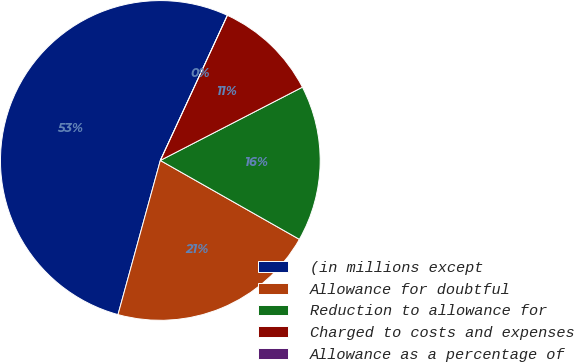Convert chart. <chart><loc_0><loc_0><loc_500><loc_500><pie_chart><fcel>(in millions except<fcel>Allowance for doubtful<fcel>Reduction to allowance for<fcel>Charged to costs and expenses<fcel>Allowance as a percentage of<nl><fcel>52.62%<fcel>21.05%<fcel>15.79%<fcel>10.53%<fcel>0.0%<nl></chart> 